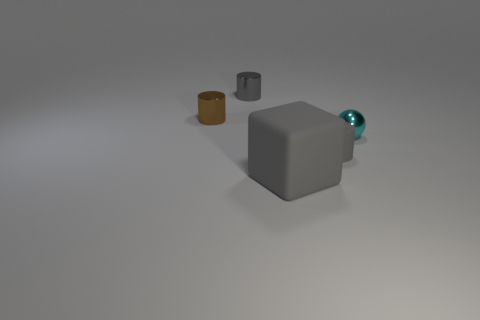Is there any other thing that is the same size as the matte block?
Provide a short and direct response. No. Are there fewer brown cylinders right of the big gray thing than small cyan metallic things right of the tiny cyan metal ball?
Your answer should be compact. No. Does the brown thing have the same material as the small cylinder on the right side of the large thing?
Your response must be concise. No. Is there any other thing that is made of the same material as the gray cube?
Your answer should be compact. Yes. Are there more tiny brown metal things than brown shiny cubes?
Provide a short and direct response. Yes. What shape is the tiny gray object that is left of the gray cylinder on the right side of the small gray thing that is left of the small matte object?
Give a very brief answer. Cylinder. Is the material of the tiny gray cylinder in front of the brown shiny cylinder the same as the object to the left of the gray metallic object?
Ensure brevity in your answer.  No. The brown object that is made of the same material as the cyan sphere is what shape?
Provide a succinct answer. Cylinder. Are there any other things that have the same color as the large block?
Keep it short and to the point. Yes. What number of small cylinders are there?
Provide a succinct answer. 3. 